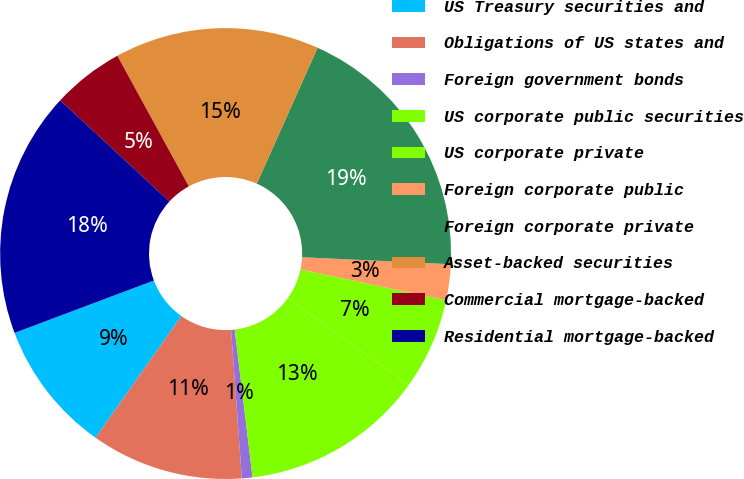Convert chart. <chart><loc_0><loc_0><loc_500><loc_500><pie_chart><fcel>US Treasury securities and<fcel>Obligations of US states and<fcel>Foreign government bonds<fcel>US corporate public securities<fcel>US corporate private<fcel>Foreign corporate public<fcel>Foreign corporate private<fcel>Asset-backed securities<fcel>Commercial mortgage-backed<fcel>Residential mortgage-backed<nl><fcel>9.49%<fcel>10.94%<fcel>0.76%<fcel>13.18%<fcel>6.59%<fcel>2.57%<fcel>19.07%<fcel>14.66%<fcel>5.14%<fcel>17.62%<nl></chart> 